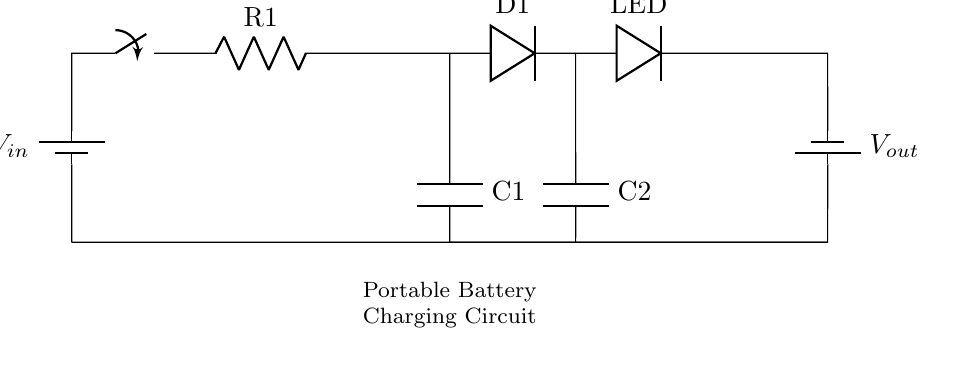What is the primary function of this circuit? The primary function is to charge a portable battery while keeping electronic devices powered. This is indicated by the presence of connections to batteries and components associated with charging and power delivery.
Answer: charge portable battery What is the value of the resistor labeled R1? The circuit diagram does not specify the resistance value for R1; it typically depends on the specific application or circuit configuration.
Answer: unspecified What type of diode is represented by D1? D1 is a standard diode, as indicated by the symbol used in the circuit. This component allows current to flow in one direction, which is crucial for rectifying the current in charging applications.
Answer: standard diode How many capacitors are present in the circuit? There are two capacitors (C1 and C2) shown in the circuit diagram, which are used to store charge and stabilize voltage levels in the circuit.
Answer: two What happens when the switch is closed? Closing the switch allows current to flow through the circuit, starting the charging process for the batteries while powering connected devices. The switch controls the flow of electricity, connecting or disconnecting the power source.
Answer: current flows What is the purpose of the LED in the circuit? The LED serves as an indicator that the circuit is active, showing that power is flowing. When the circuit operates correctly, the LED lights up, providing a visual cue that the device is charging or powered.
Answer: power indicator What is the input voltage labeled V_in? The circuit does not specify a numerical value for V_in; this would typically be the voltage provided by an external source, such as a wall adapter or solar panel, required to charge the battery effectively.
Answer: unspecified 